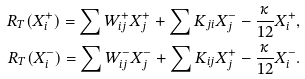Convert formula to latex. <formula><loc_0><loc_0><loc_500><loc_500>R _ { T } ( X _ { i } ^ { + } ) = \sum W ^ { + } _ { i j } X _ { j } ^ { + } + \sum K _ { j i } X _ { j } ^ { - } - \frac { \kappa } { 1 2 } X _ { i } ^ { + } , \\ R _ { T } ( X _ { i } ^ { - } ) = \sum W ^ { - } _ { i j } X ^ { - } _ { j } + \sum K _ { i j } X _ { j } ^ { + } - \frac { \kappa } { 1 2 } X _ { i } ^ { - } .</formula> 